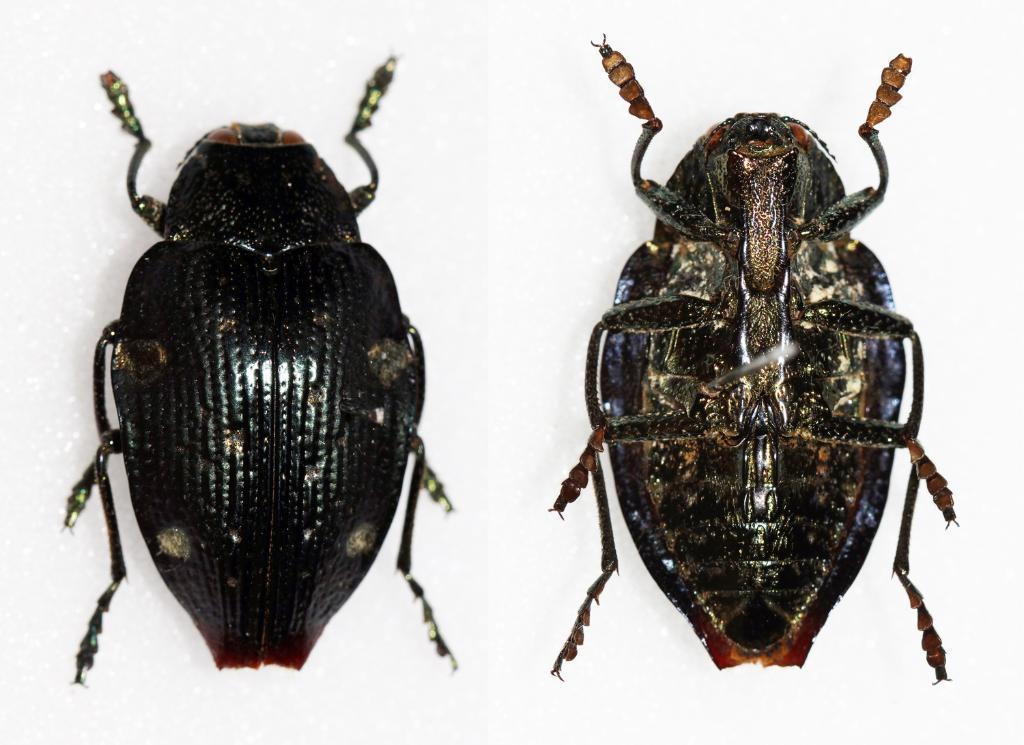What type of living organism can be seen in the image? The image contains an insect. Can you describe the insect's physical structure? The insect has an outer layer and an inner layer. What is the color of the background in the image? The background of the image is white. What type of pancake can be seen in the image? There is no pancake present in the image; it features an insect with an outer and inner layer. Can you tell me how the crook is using the cork in the image? There is no crook or cork present in the image; it only contains an insect and a white background. 